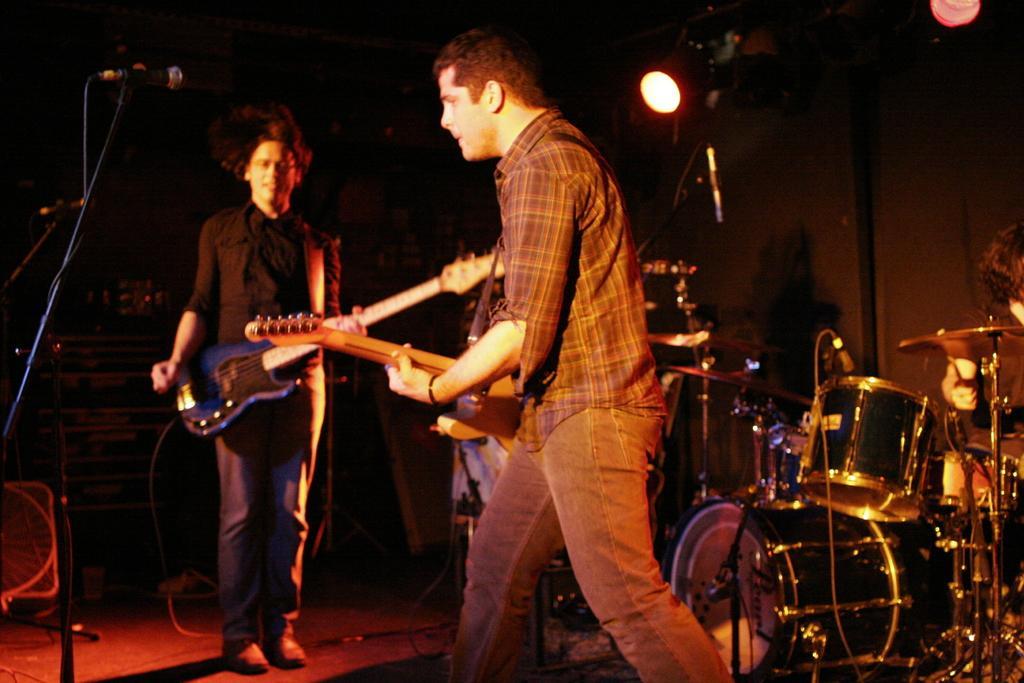Describe this image in one or two sentences. In this picture there three persons this person is standing in holding the guitar with his left hand and this person is walking and holding the guitar lesson right hand and the microphone in front of them in the backdrop there is a drum set and there is a person sitting over here and there disco lights attached to the ceiling 